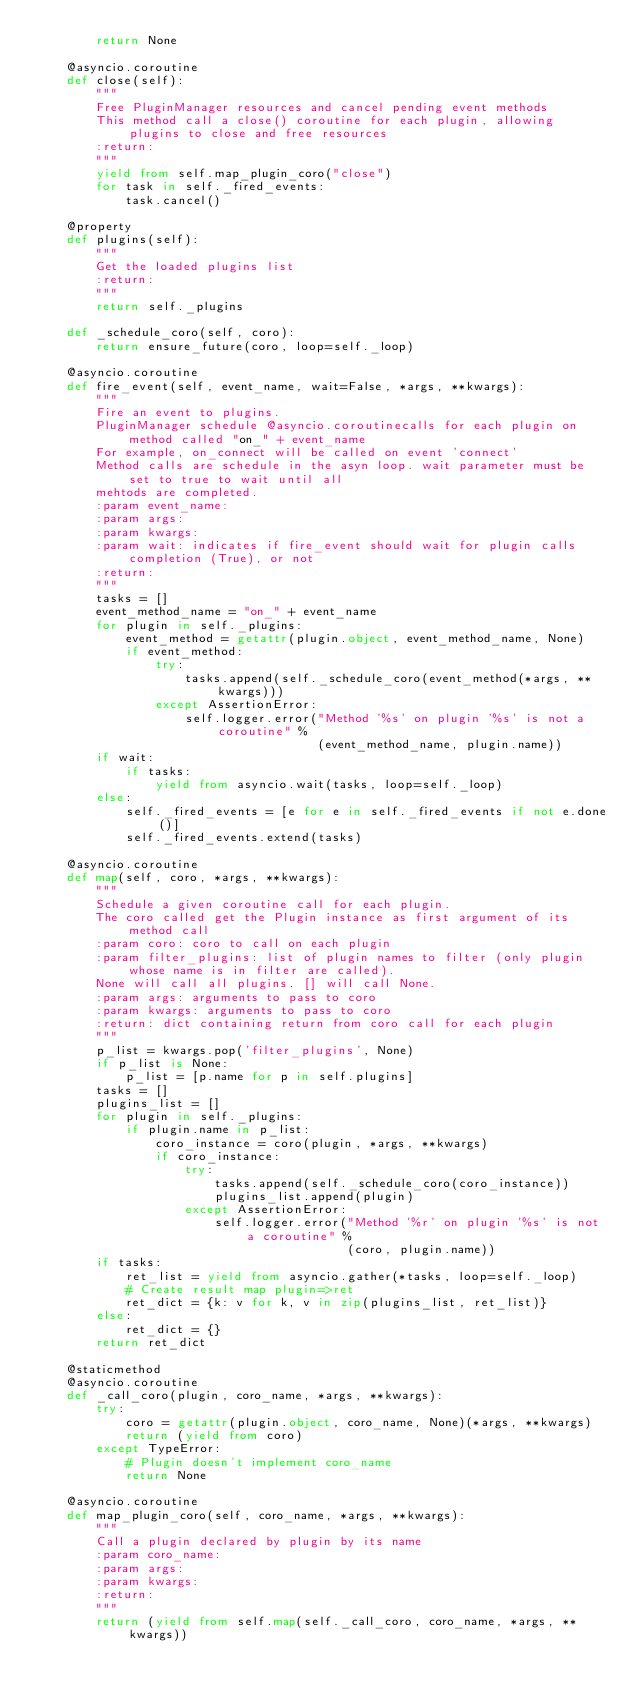<code> <loc_0><loc_0><loc_500><loc_500><_Python_>        return None

    @asyncio.coroutine
    def close(self):
        """
        Free PluginManager resources and cancel pending event methods
        This method call a close() coroutine for each plugin, allowing plugins to close and free resources
        :return:
        """
        yield from self.map_plugin_coro("close")
        for task in self._fired_events:
            task.cancel()

    @property
    def plugins(self):
        """
        Get the loaded plugins list
        :return:
        """
        return self._plugins

    def _schedule_coro(self, coro):
        return ensure_future(coro, loop=self._loop)

    @asyncio.coroutine
    def fire_event(self, event_name, wait=False, *args, **kwargs):
        """
        Fire an event to plugins.
        PluginManager schedule @asyncio.coroutinecalls for each plugin on method called "on_" + event_name
        For example, on_connect will be called on event 'connect'
        Method calls are schedule in the asyn loop. wait parameter must be set to true to wait until all
        mehtods are completed.
        :param event_name:
        :param args:
        :param kwargs:
        :param wait: indicates if fire_event should wait for plugin calls completion (True), or not
        :return:
        """
        tasks = []
        event_method_name = "on_" + event_name
        for plugin in self._plugins:
            event_method = getattr(plugin.object, event_method_name, None)
            if event_method:
                try:
                    tasks.append(self._schedule_coro(event_method(*args, **kwargs)))
                except AssertionError:
                    self.logger.error("Method '%s' on plugin '%s' is not a coroutine" %
                                      (event_method_name, plugin.name))
        if wait:
            if tasks:
                yield from asyncio.wait(tasks, loop=self._loop)
        else:
            self._fired_events = [e for e in self._fired_events if not e.done()]
            self._fired_events.extend(tasks)

    @asyncio.coroutine
    def map(self, coro, *args, **kwargs):
        """
        Schedule a given coroutine call for each plugin.
        The coro called get the Plugin instance as first argument of its method call
        :param coro: coro to call on each plugin
        :param filter_plugins: list of plugin names to filter (only plugin whose name is in filter are called).
        None will call all plugins. [] will call None.
        :param args: arguments to pass to coro
        :param kwargs: arguments to pass to coro
        :return: dict containing return from coro call for each plugin
        """
        p_list = kwargs.pop('filter_plugins', None)
        if p_list is None:
            p_list = [p.name for p in self.plugins]
        tasks = []
        plugins_list = []
        for plugin in self._plugins:
            if plugin.name in p_list:
                coro_instance = coro(plugin, *args, **kwargs)
                if coro_instance:
                    try:
                        tasks.append(self._schedule_coro(coro_instance))
                        plugins_list.append(plugin)
                    except AssertionError:
                        self.logger.error("Method '%r' on plugin '%s' is not a coroutine" %
                                          (coro, plugin.name))
        if tasks:
            ret_list = yield from asyncio.gather(*tasks, loop=self._loop)
            # Create result map plugin=>ret
            ret_dict = {k: v for k, v in zip(plugins_list, ret_list)}
        else:
            ret_dict = {}
        return ret_dict

    @staticmethod
    @asyncio.coroutine
    def _call_coro(plugin, coro_name, *args, **kwargs):
        try:
            coro = getattr(plugin.object, coro_name, None)(*args, **kwargs)
            return (yield from coro)
        except TypeError:
            # Plugin doesn't implement coro_name
            return None

    @asyncio.coroutine
    def map_plugin_coro(self, coro_name, *args, **kwargs):
        """
        Call a plugin declared by plugin by its name
        :param coro_name:
        :param args:
        :param kwargs:
        :return:
        """
        return (yield from self.map(self._call_coro, coro_name, *args, **kwargs))
</code> 